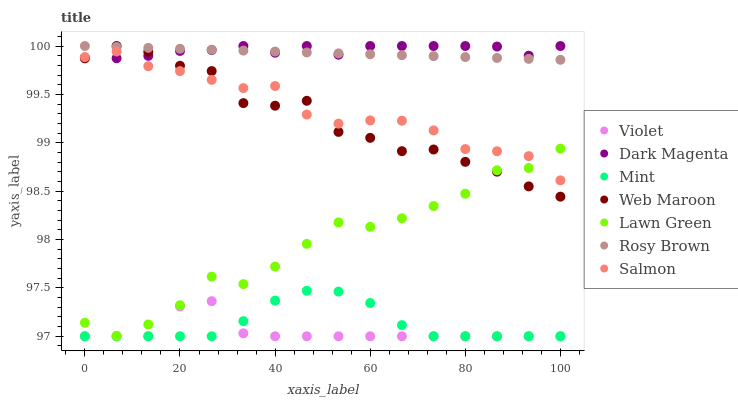Does Violet have the minimum area under the curve?
Answer yes or no. Yes. Does Dark Magenta have the maximum area under the curve?
Answer yes or no. Yes. Does Salmon have the minimum area under the curve?
Answer yes or no. No. Does Salmon have the maximum area under the curve?
Answer yes or no. No. Is Rosy Brown the smoothest?
Answer yes or no. Yes. Is Web Maroon the roughest?
Answer yes or no. Yes. Is Dark Magenta the smoothest?
Answer yes or no. No. Is Dark Magenta the roughest?
Answer yes or no. No. Does Violet have the lowest value?
Answer yes or no. Yes. Does Salmon have the lowest value?
Answer yes or no. No. Does Web Maroon have the highest value?
Answer yes or no. Yes. Does Salmon have the highest value?
Answer yes or no. No. Is Mint less than Web Maroon?
Answer yes or no. Yes. Is Rosy Brown greater than Mint?
Answer yes or no. Yes. Does Salmon intersect Lawn Green?
Answer yes or no. Yes. Is Salmon less than Lawn Green?
Answer yes or no. No. Is Salmon greater than Lawn Green?
Answer yes or no. No. Does Mint intersect Web Maroon?
Answer yes or no. No. 